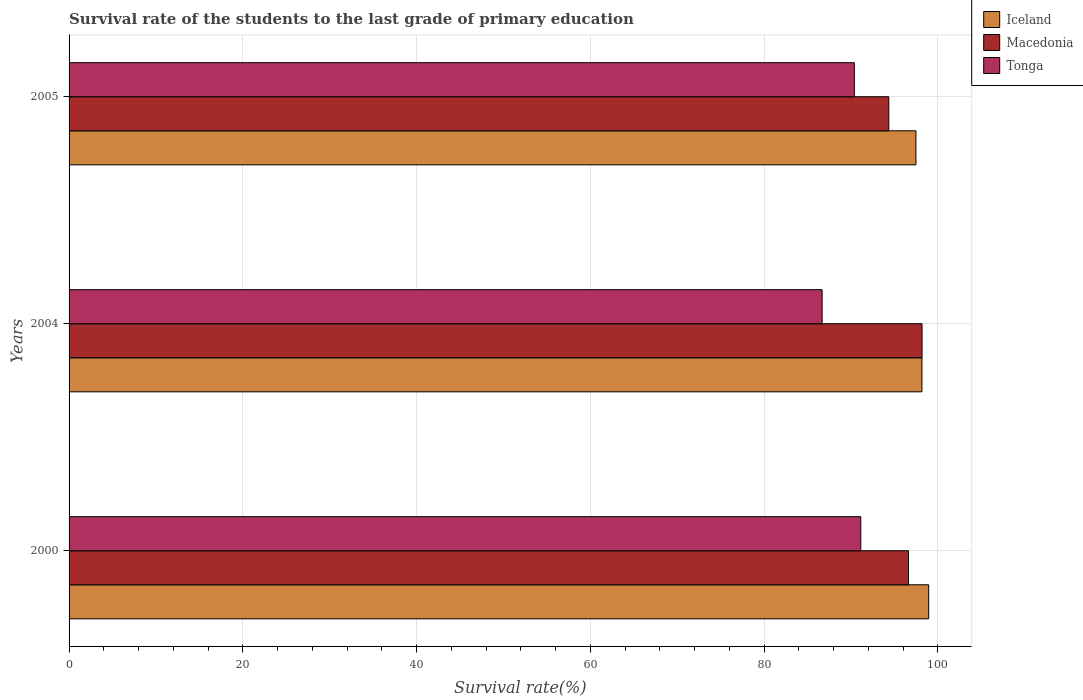How many different coloured bars are there?
Provide a succinct answer. 3. Are the number of bars per tick equal to the number of legend labels?
Ensure brevity in your answer.  Yes. Are the number of bars on each tick of the Y-axis equal?
Give a very brief answer. Yes. How many bars are there on the 3rd tick from the top?
Make the answer very short. 3. What is the survival rate of the students in Tonga in 2005?
Provide a succinct answer. 90.39. Across all years, what is the maximum survival rate of the students in Macedonia?
Provide a short and direct response. 98.18. Across all years, what is the minimum survival rate of the students in Iceland?
Provide a succinct answer. 97.48. In which year was the survival rate of the students in Iceland minimum?
Your answer should be compact. 2005. What is the total survival rate of the students in Iceland in the graph?
Your answer should be compact. 294.6. What is the difference between the survival rate of the students in Tonga in 2000 and that in 2005?
Keep it short and to the point. 0.74. What is the difference between the survival rate of the students in Iceland in 2005 and the survival rate of the students in Tonga in 2000?
Your answer should be compact. 6.35. What is the average survival rate of the students in Macedonia per year?
Keep it short and to the point. 96.38. In the year 2005, what is the difference between the survival rate of the students in Iceland and survival rate of the students in Tonga?
Make the answer very short. 7.09. In how many years, is the survival rate of the students in Macedonia greater than 80 %?
Your response must be concise. 3. What is the ratio of the survival rate of the students in Macedonia in 2000 to that in 2004?
Make the answer very short. 0.98. Is the survival rate of the students in Iceland in 2000 less than that in 2004?
Your answer should be compact. No. What is the difference between the highest and the second highest survival rate of the students in Tonga?
Offer a very short reply. 0.74. What is the difference between the highest and the lowest survival rate of the students in Iceland?
Keep it short and to the point. 1.47. What does the 3rd bar from the top in 2004 represents?
Keep it short and to the point. Iceland. What does the 2nd bar from the bottom in 2000 represents?
Give a very brief answer. Macedonia. How many bars are there?
Your response must be concise. 9. How many legend labels are there?
Provide a succinct answer. 3. How are the legend labels stacked?
Provide a short and direct response. Vertical. What is the title of the graph?
Give a very brief answer. Survival rate of the students to the last grade of primary education. What is the label or title of the X-axis?
Offer a terse response. Survival rate(%). What is the label or title of the Y-axis?
Keep it short and to the point. Years. What is the Survival rate(%) of Iceland in 2000?
Make the answer very short. 98.95. What is the Survival rate(%) in Macedonia in 2000?
Make the answer very short. 96.62. What is the Survival rate(%) of Tonga in 2000?
Your response must be concise. 91.13. What is the Survival rate(%) in Iceland in 2004?
Your response must be concise. 98.17. What is the Survival rate(%) in Macedonia in 2004?
Give a very brief answer. 98.18. What is the Survival rate(%) in Tonga in 2004?
Provide a succinct answer. 86.68. What is the Survival rate(%) of Iceland in 2005?
Your answer should be very brief. 97.48. What is the Survival rate(%) in Macedonia in 2005?
Offer a terse response. 94.35. What is the Survival rate(%) of Tonga in 2005?
Offer a very short reply. 90.39. Across all years, what is the maximum Survival rate(%) of Iceland?
Offer a very short reply. 98.95. Across all years, what is the maximum Survival rate(%) in Macedonia?
Provide a short and direct response. 98.18. Across all years, what is the maximum Survival rate(%) in Tonga?
Keep it short and to the point. 91.13. Across all years, what is the minimum Survival rate(%) of Iceland?
Make the answer very short. 97.48. Across all years, what is the minimum Survival rate(%) in Macedonia?
Make the answer very short. 94.35. Across all years, what is the minimum Survival rate(%) of Tonga?
Your answer should be very brief. 86.68. What is the total Survival rate(%) in Iceland in the graph?
Provide a short and direct response. 294.6. What is the total Survival rate(%) of Macedonia in the graph?
Your answer should be very brief. 289.15. What is the total Survival rate(%) in Tonga in the graph?
Offer a very short reply. 268.2. What is the difference between the Survival rate(%) in Iceland in 2000 and that in 2004?
Your answer should be compact. 0.78. What is the difference between the Survival rate(%) in Macedonia in 2000 and that in 2004?
Make the answer very short. -1.56. What is the difference between the Survival rate(%) in Tonga in 2000 and that in 2004?
Your response must be concise. 4.45. What is the difference between the Survival rate(%) of Iceland in 2000 and that in 2005?
Provide a succinct answer. 1.47. What is the difference between the Survival rate(%) in Macedonia in 2000 and that in 2005?
Give a very brief answer. 2.27. What is the difference between the Survival rate(%) of Tonga in 2000 and that in 2005?
Keep it short and to the point. 0.74. What is the difference between the Survival rate(%) of Iceland in 2004 and that in 2005?
Make the answer very short. 0.69. What is the difference between the Survival rate(%) of Macedonia in 2004 and that in 2005?
Your answer should be compact. 3.83. What is the difference between the Survival rate(%) in Tonga in 2004 and that in 2005?
Offer a very short reply. -3.71. What is the difference between the Survival rate(%) of Iceland in 2000 and the Survival rate(%) of Macedonia in 2004?
Your answer should be very brief. 0.77. What is the difference between the Survival rate(%) of Iceland in 2000 and the Survival rate(%) of Tonga in 2004?
Make the answer very short. 12.27. What is the difference between the Survival rate(%) in Macedonia in 2000 and the Survival rate(%) in Tonga in 2004?
Keep it short and to the point. 9.94. What is the difference between the Survival rate(%) of Iceland in 2000 and the Survival rate(%) of Macedonia in 2005?
Offer a very short reply. 4.6. What is the difference between the Survival rate(%) in Iceland in 2000 and the Survival rate(%) in Tonga in 2005?
Provide a succinct answer. 8.56. What is the difference between the Survival rate(%) in Macedonia in 2000 and the Survival rate(%) in Tonga in 2005?
Provide a succinct answer. 6.23. What is the difference between the Survival rate(%) of Iceland in 2004 and the Survival rate(%) of Macedonia in 2005?
Your response must be concise. 3.82. What is the difference between the Survival rate(%) in Iceland in 2004 and the Survival rate(%) in Tonga in 2005?
Ensure brevity in your answer.  7.78. What is the difference between the Survival rate(%) in Macedonia in 2004 and the Survival rate(%) in Tonga in 2005?
Provide a succinct answer. 7.79. What is the average Survival rate(%) of Iceland per year?
Give a very brief answer. 98.2. What is the average Survival rate(%) in Macedonia per year?
Keep it short and to the point. 96.38. What is the average Survival rate(%) of Tonga per year?
Your response must be concise. 89.4. In the year 2000, what is the difference between the Survival rate(%) of Iceland and Survival rate(%) of Macedonia?
Offer a terse response. 2.33. In the year 2000, what is the difference between the Survival rate(%) of Iceland and Survival rate(%) of Tonga?
Provide a succinct answer. 7.82. In the year 2000, what is the difference between the Survival rate(%) in Macedonia and Survival rate(%) in Tonga?
Your answer should be compact. 5.49. In the year 2004, what is the difference between the Survival rate(%) in Iceland and Survival rate(%) in Macedonia?
Provide a short and direct response. -0.01. In the year 2004, what is the difference between the Survival rate(%) in Iceland and Survival rate(%) in Tonga?
Offer a terse response. 11.49. In the year 2004, what is the difference between the Survival rate(%) in Macedonia and Survival rate(%) in Tonga?
Offer a terse response. 11.5. In the year 2005, what is the difference between the Survival rate(%) in Iceland and Survival rate(%) in Macedonia?
Provide a succinct answer. 3.12. In the year 2005, what is the difference between the Survival rate(%) in Iceland and Survival rate(%) in Tonga?
Provide a short and direct response. 7.09. In the year 2005, what is the difference between the Survival rate(%) of Macedonia and Survival rate(%) of Tonga?
Provide a short and direct response. 3.96. What is the ratio of the Survival rate(%) of Iceland in 2000 to that in 2004?
Provide a short and direct response. 1.01. What is the ratio of the Survival rate(%) in Macedonia in 2000 to that in 2004?
Your response must be concise. 0.98. What is the ratio of the Survival rate(%) in Tonga in 2000 to that in 2004?
Provide a succinct answer. 1.05. What is the ratio of the Survival rate(%) in Iceland in 2000 to that in 2005?
Keep it short and to the point. 1.02. What is the ratio of the Survival rate(%) in Macedonia in 2000 to that in 2005?
Ensure brevity in your answer.  1.02. What is the ratio of the Survival rate(%) of Tonga in 2000 to that in 2005?
Offer a very short reply. 1.01. What is the ratio of the Survival rate(%) in Iceland in 2004 to that in 2005?
Ensure brevity in your answer.  1.01. What is the ratio of the Survival rate(%) in Macedonia in 2004 to that in 2005?
Ensure brevity in your answer.  1.04. What is the ratio of the Survival rate(%) of Tonga in 2004 to that in 2005?
Make the answer very short. 0.96. What is the difference between the highest and the second highest Survival rate(%) in Iceland?
Offer a terse response. 0.78. What is the difference between the highest and the second highest Survival rate(%) in Macedonia?
Your answer should be very brief. 1.56. What is the difference between the highest and the second highest Survival rate(%) in Tonga?
Provide a short and direct response. 0.74. What is the difference between the highest and the lowest Survival rate(%) in Iceland?
Keep it short and to the point. 1.47. What is the difference between the highest and the lowest Survival rate(%) in Macedonia?
Give a very brief answer. 3.83. What is the difference between the highest and the lowest Survival rate(%) in Tonga?
Your response must be concise. 4.45. 